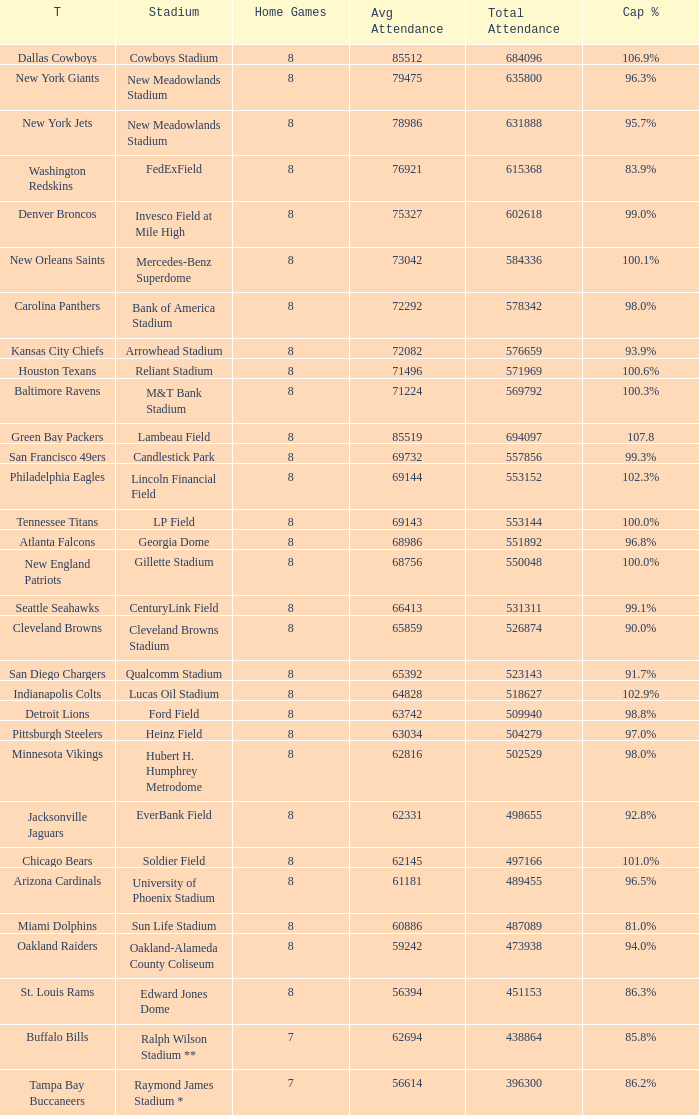What is the name of the stadium when the capacity percentage is 83.9% FedExField. 